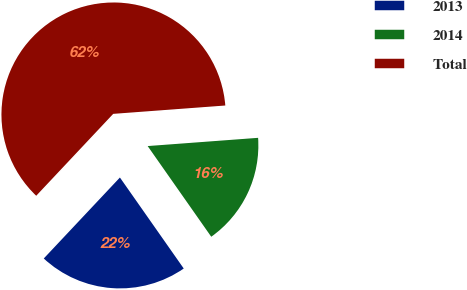Convert chart. <chart><loc_0><loc_0><loc_500><loc_500><pie_chart><fcel>2013<fcel>2014<fcel>Total<nl><fcel>21.74%<fcel>16.45%<fcel>61.8%<nl></chart> 